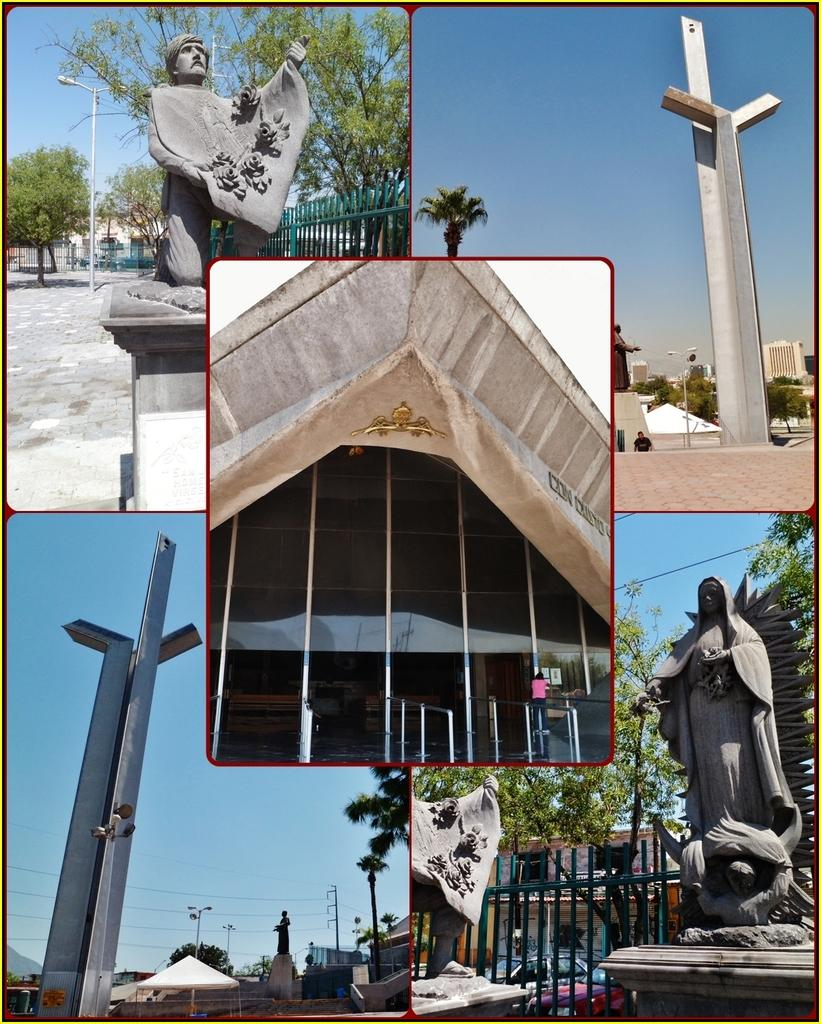What type of images are present in the image? The images contain sculptures and boards. What type of structures can be seen in the image? There is a fence and a building visible in the image. What type of natural elements can be seen in the image? Trees and the sky are visible in the image. What language is being spoken by the coach in the image? There is no coach or language spoken in the image; it only contains pictures of sculptures and boards, as well as other elements like trees, a fence, a building, and the sky. 